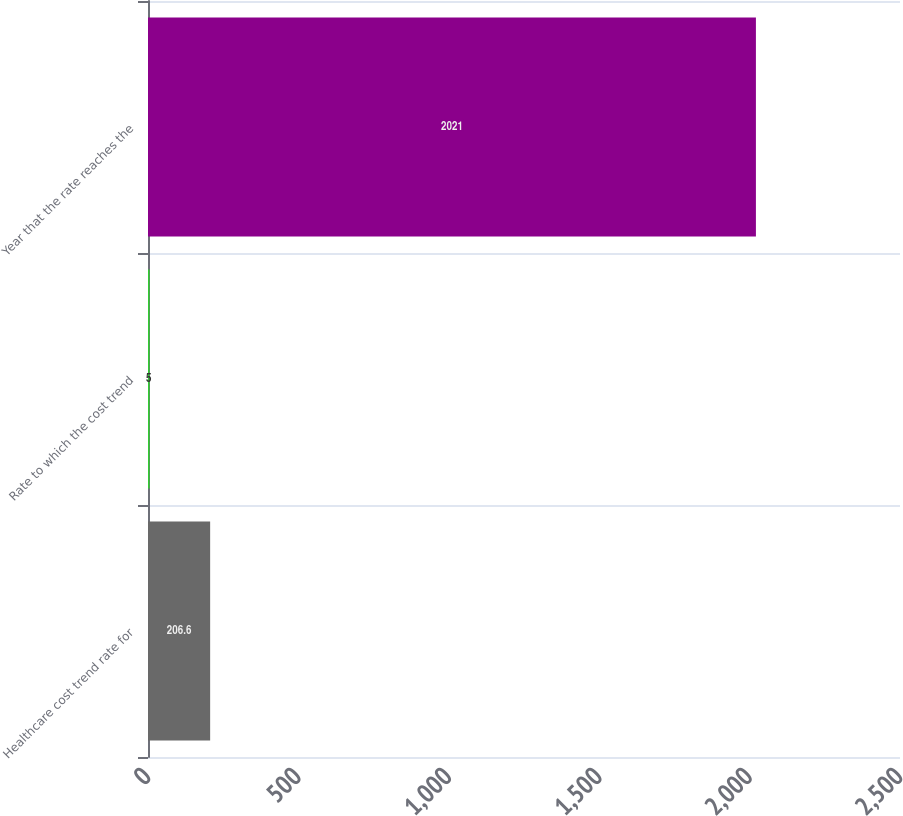Convert chart. <chart><loc_0><loc_0><loc_500><loc_500><bar_chart><fcel>Healthcare cost trend rate for<fcel>Rate to which the cost trend<fcel>Year that the rate reaches the<nl><fcel>206.6<fcel>5<fcel>2021<nl></chart> 